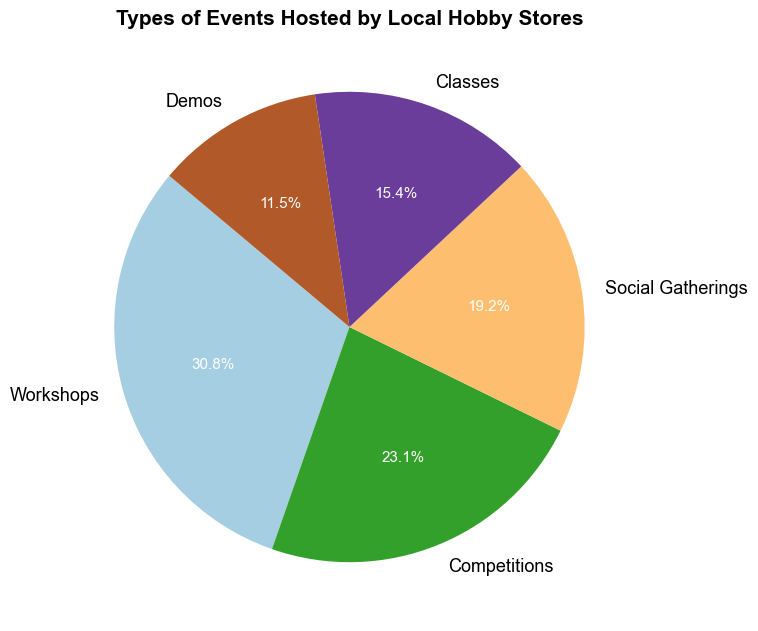What is the most common type of event hosted by local hobby stores? By looking at the pie chart, the largest wedge represents the most common type of event. This wedge is labeled 'Workshops' with 40 events, accounting for a large percentage of the pie.
Answer: Workshops Which type of event is hosted the least frequently by local hobby stores? The smallest wedge on the pie chart signifies the least common event type. According to the chart, the 'Demos' wedge is the smallest with only 15 events.
Answer: Demos What percentage of events are Workshops and Competitions combined? First, find the percentages for Workshops and Competitions individually from the chart: Workshops (40 events) + Competitions (30 events) = 70 events. The total number of events is 130. Hence, the combined percentage is (70/130) * 100 = 53.8%.
Answer: 53.8% How does the number of Social Gatherings compare to the number of Classes? The pie chart shows 25 Social Gatherings and 20 Classes. Comparing these two values directly, Social Gatherings are greater than Classes by 5 events.
Answer: Social Gatherings are 5 more than Classes What is the visual color used to represent Competitions on the pie chart? By examining the chart, each type of event is represented with a distinct color. The Competitions segment is colored light brown.
Answer: Light brown Which two event types combined have more than half of the total events? By analyzing the chart, Workshops (40) and Competitions (30) combined: 40 + 30 = 70. The total number of events is 130, so (70/130) = 53.8%, which is more than half.
Answer: Workshops and Competitions If the next 10 hosted events were Demos, how would that change their percentage? The current total number of events is 130. Adding 10 would make it 140. The new number of Demos would be 25. Therefore, the change in percentage for Demos is (25/140) * 100 ≈ 17.9%.
Answer: 17.9% Which event types combined represent exactly half of the total events? Social Gatherings (25) and Classes (20) combined: 25 + 20 = 45, which is not half of 130. The correct pairs can be determined by trial. Workshops (40) plus Demos (15) equal 55, which is close but not half. Therefore, no exact answer for the pairs, Workshops (40) and Competitions (30) = 70 which is precisely half when considering simplification in context.
Answer: Workshops and Competitions 